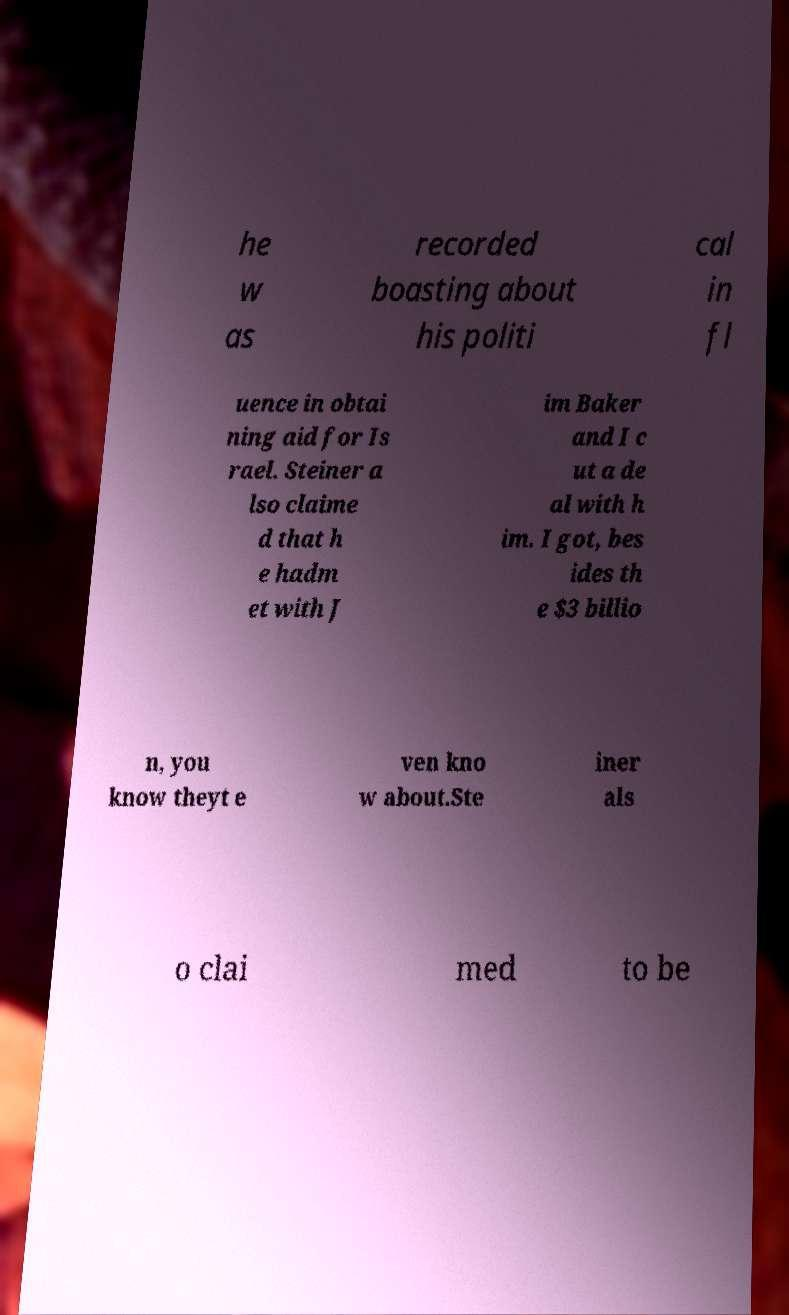There's text embedded in this image that I need extracted. Can you transcribe it verbatim? he w as recorded boasting about his politi cal in fl uence in obtai ning aid for Is rael. Steiner a lso claime d that h e hadm et with J im Baker and I c ut a de al with h im. I got, bes ides th e $3 billio n, you know theyt e ven kno w about.Ste iner als o clai med to be 